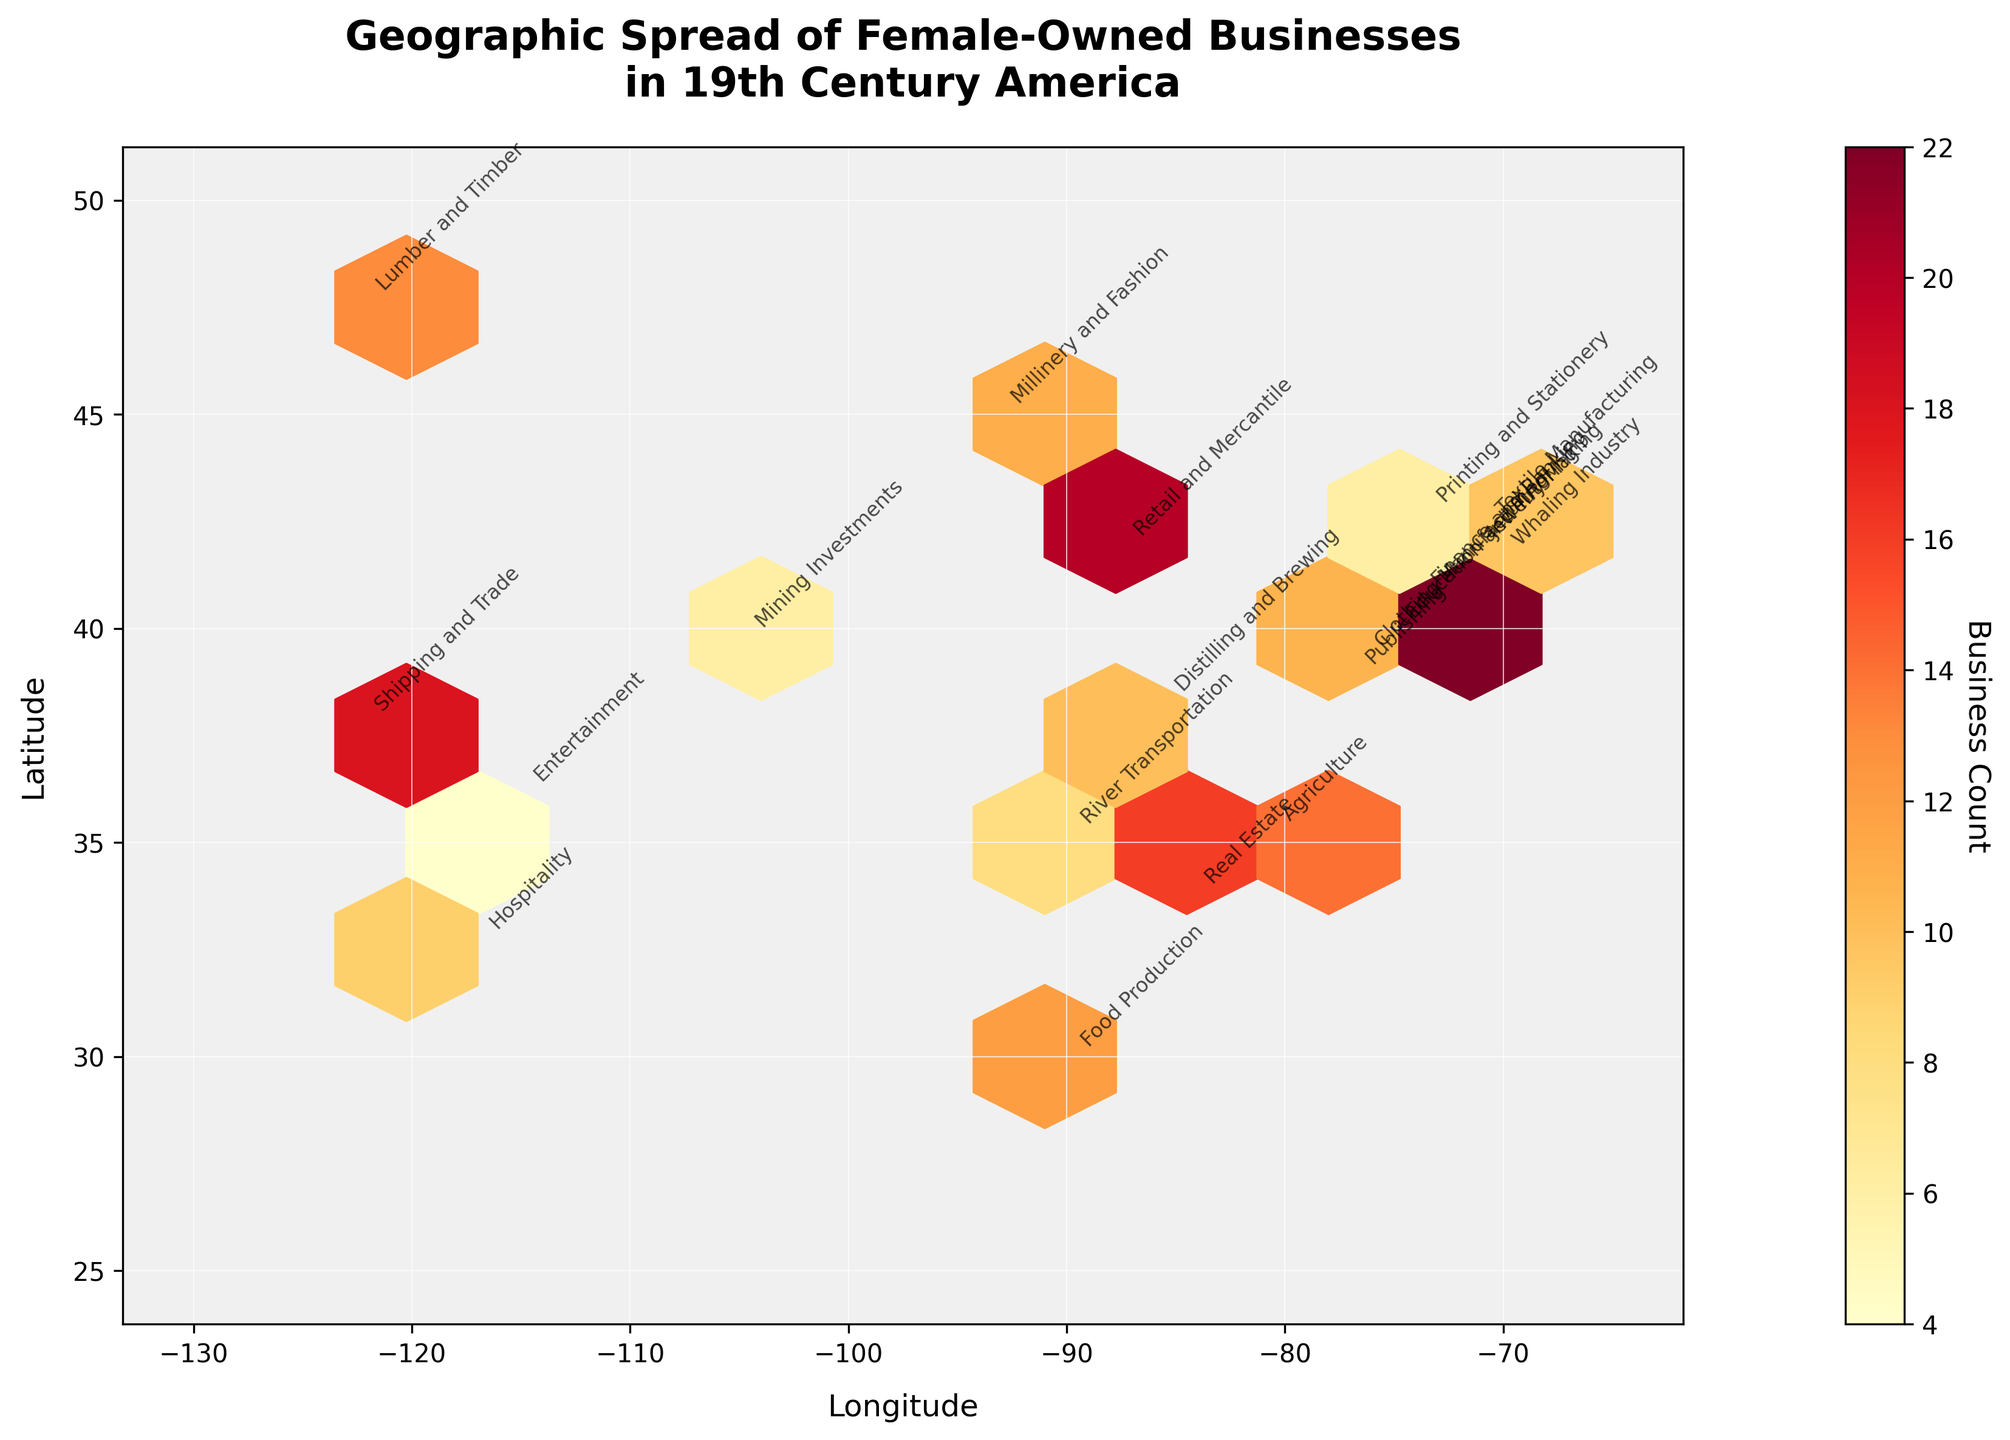Which city has the highest concentration of female-owned businesses? The hexbin plot shows various concentrations of businesses across cities. The color bar represents the business count, with darker shades indicating higher concentrations. By observing the darkest shade in the plot, we identify that New York (longitude -74.0060, latitude 40.7128) has the highest concentration.
Answer: New York What industry is represented by the business in Philadelphia? By locating Philadelphia on the plot (longitude -75.1652, latitude 39.9526) and observing the annotation, we see that the industry is Education and Tutoring.
Answer: Education and Tutoring Between Boston and New Orleans, which city has more female-owned businesses in the 19th century? From the plot, Boston is at longitude -71.0589, latitude 42.3601, and has a business count indicated by a lighter hexagon compared to New Orleans at longitude -90.0715, latitude 29.9511. By checking the color shade and respective annotations, New Orleans (with Food Production) has more compared to Boston (with Textile Manufacturing).
Answer: New Orleans What is the primary industry type in Denver? Denver is located at approximately longitude -104.9903, latitude 39.7392. Observing the annotation at this location on the hexbin plot, the primary industry is Mining Investments.
Answer: Mining Investments How many cities have business profiles related to manufacturing? By examining the annotations, we identify 'Textile Manufacturing' at Boston, 'Clothing Manufacturing' at Baltimore (longitude -76.6122, latitude 39.2904), a total of 2 cities.
Answer: 2 Is there a higher concentration of female-owned businesses in the East or West of the United States? By comparing the density and color of hexagons on the east (right side of the map) and west (left side of the map), the eastern side, including cities like New York and Baltimore, has more and darker-colored hexagons, indicating a higher concentration.
Answer: East Which industry is predominant in the Southern states? Observing the Southern cities and their annotations, we note 'Food Production' in New Orleans, 'Agriculture' in Charlotte (longitude -80.8431, latitude 35.2271), and 'Distilling and Brewing' in Louisville (longitude -85.7585, latitude 38.2527). "Food Production" slightly emerges among those.
Answer: Food Production What city is associated with the Whaling Industry? Finding the annotation for the Whaling Industry in the plot, we locate it at longitude -70.2881, latitude 41.6532, which corresponds to the city of New Bedford, Massachusetts.
Answer: New Bedford How does the concentration of businesses in San Francisco compare to that in Boston? Comparing the color and density of the respective hexagons at San Francisco (longitude -122.4194, latitude 37.7749) and Boston (longitude -71.0589, latitude 42.3601), the San Francisco hexagon is darker, indicating a greater concentration of businesses.
Answer: San Francisco 